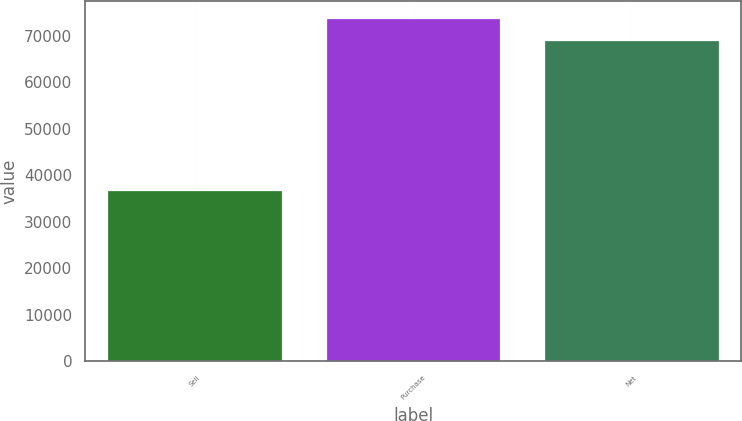Convert chart. <chart><loc_0><loc_0><loc_500><loc_500><bar_chart><fcel>Sell<fcel>Purchase<fcel>Net<nl><fcel>36938<fcel>73914<fcel>69104<nl></chart> 